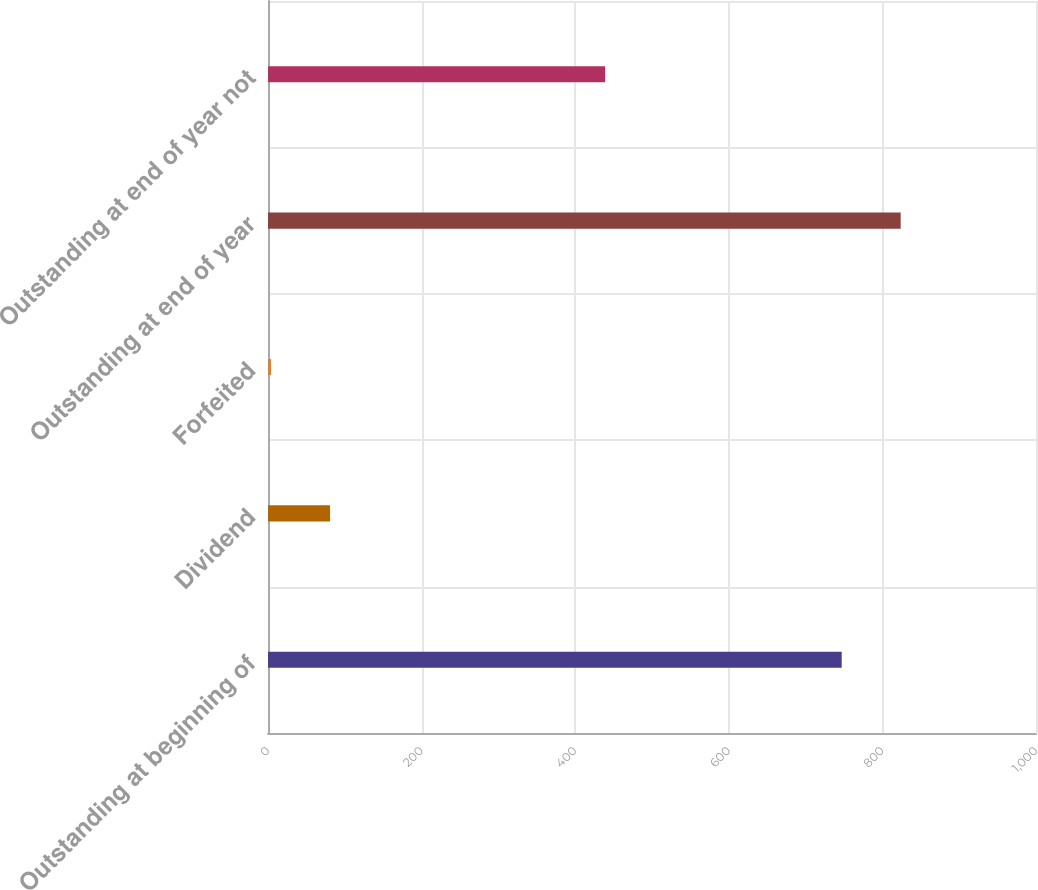Convert chart to OTSL. <chart><loc_0><loc_0><loc_500><loc_500><bar_chart><fcel>Outstanding at beginning of<fcel>Dividend<fcel>Forfeited<fcel>Outstanding at end of year<fcel>Outstanding at end of year not<nl><fcel>747<fcel>80.8<fcel>4<fcel>823.8<fcel>439<nl></chart> 